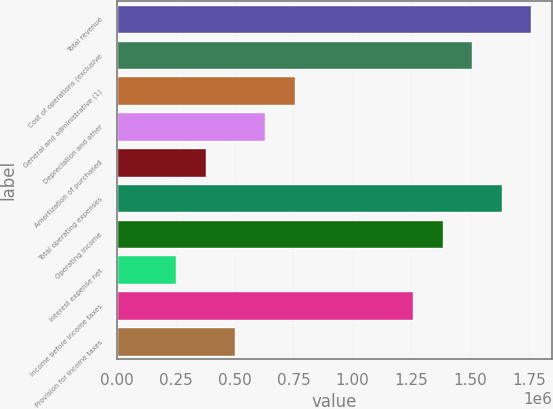Convert chart. <chart><loc_0><loc_0><loc_500><loc_500><bar_chart><fcel>Total revenue<fcel>Cost of operations (exclusive<fcel>General and administrative (1)<fcel>Depreciation and other<fcel>Amortization of purchased<fcel>Total operating expenses<fcel>Operating income<fcel>Interest expense net<fcel>Income before income taxes<fcel>Provision for income taxes<nl><fcel>1.76041e+06<fcel>1.50893e+06<fcel>754463<fcel>628720<fcel>377232<fcel>1.63467e+06<fcel>1.38318e+06<fcel>251489<fcel>1.25744e+06<fcel>502976<nl></chart> 